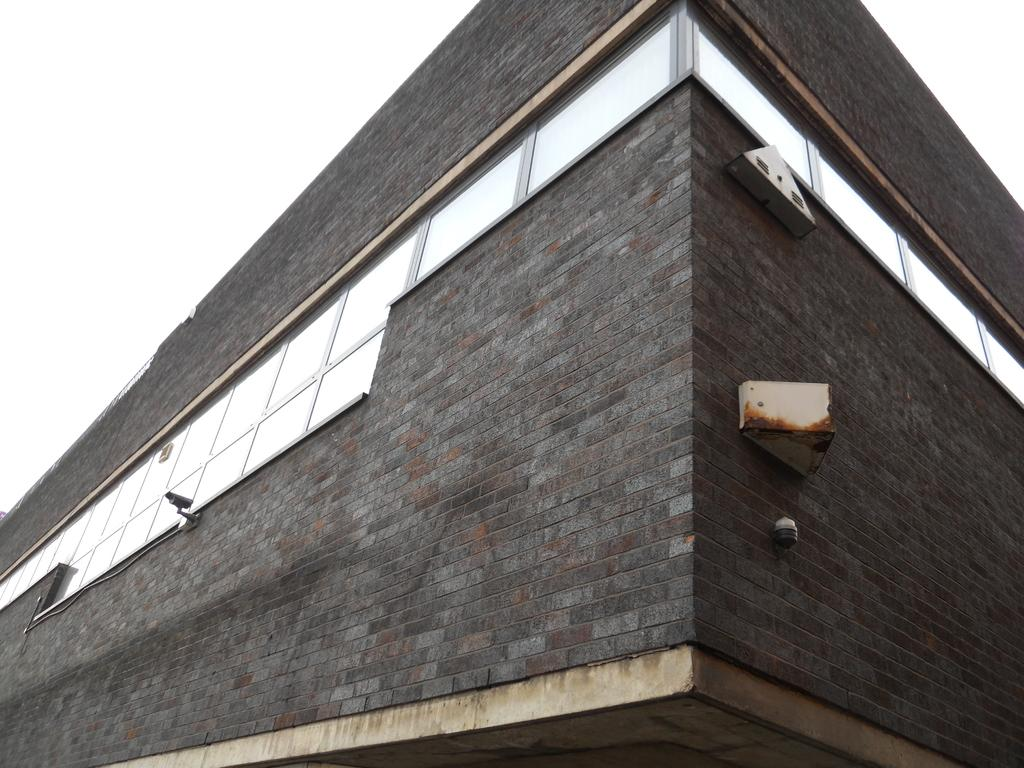What structure is present in the image? There is a building in the image. Is there any equipment attached to the building? Yes, a camera is attached to the building. What type of leather material is visible on the building in the image? There is no leather material visible on the building in the image. What type of loss is being experienced by the building in the image? There is no indication of any loss in the image; it simply shows a building with a camera attached to it. Is there a judge present in the image? There is no judge present in the image. 